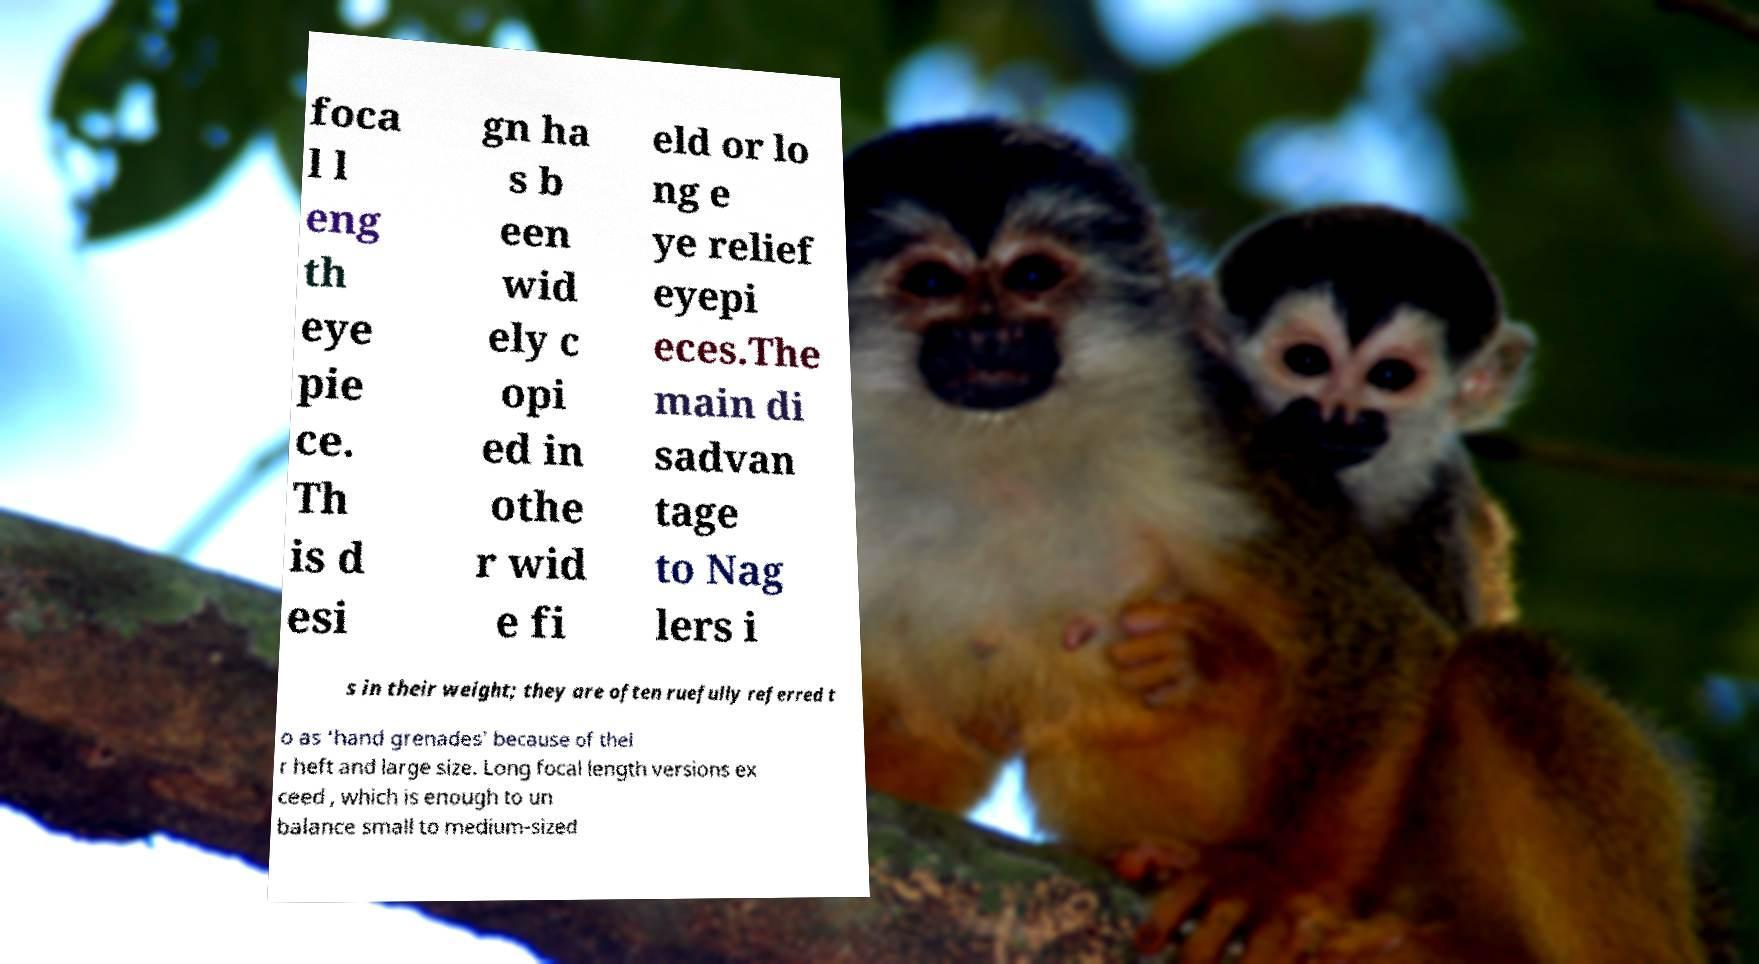For documentation purposes, I need the text within this image transcribed. Could you provide that? foca l l eng th eye pie ce. Th is d esi gn ha s b een wid ely c opi ed in othe r wid e fi eld or lo ng e ye relief eyepi eces.The main di sadvan tage to Nag lers i s in their weight; they are often ruefully referred t o as ‘hand grenades’ because of thei r heft and large size. Long focal length versions ex ceed , which is enough to un balance small to medium-sized 